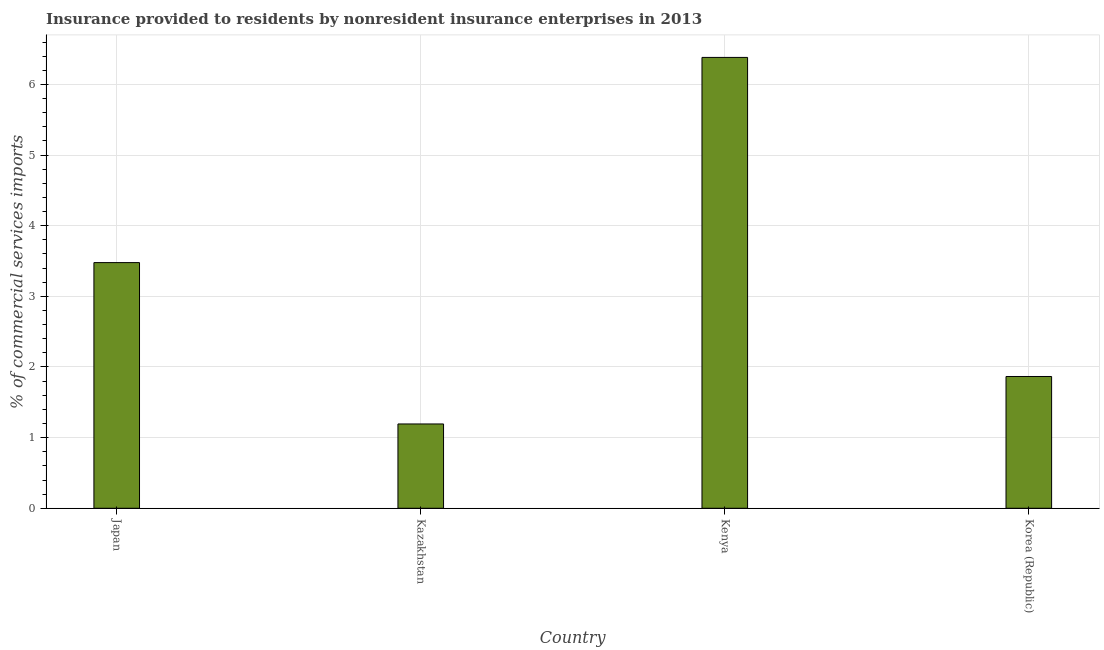What is the title of the graph?
Keep it short and to the point. Insurance provided to residents by nonresident insurance enterprises in 2013. What is the label or title of the Y-axis?
Offer a very short reply. % of commercial services imports. What is the insurance provided by non-residents in Kenya?
Provide a succinct answer. 6.38. Across all countries, what is the maximum insurance provided by non-residents?
Make the answer very short. 6.38. Across all countries, what is the minimum insurance provided by non-residents?
Provide a short and direct response. 1.19. In which country was the insurance provided by non-residents maximum?
Your response must be concise. Kenya. In which country was the insurance provided by non-residents minimum?
Offer a very short reply. Kazakhstan. What is the sum of the insurance provided by non-residents?
Ensure brevity in your answer.  12.92. What is the difference between the insurance provided by non-residents in Kazakhstan and Korea (Republic)?
Keep it short and to the point. -0.67. What is the average insurance provided by non-residents per country?
Keep it short and to the point. 3.23. What is the median insurance provided by non-residents?
Offer a very short reply. 2.67. In how many countries, is the insurance provided by non-residents greater than 4.8 %?
Your response must be concise. 1. What is the ratio of the insurance provided by non-residents in Kenya to that in Korea (Republic)?
Give a very brief answer. 3.42. Is the insurance provided by non-residents in Kazakhstan less than that in Kenya?
Give a very brief answer. Yes. Is the difference between the insurance provided by non-residents in Kazakhstan and Kenya greater than the difference between any two countries?
Keep it short and to the point. Yes. What is the difference between the highest and the second highest insurance provided by non-residents?
Keep it short and to the point. 2.9. Is the sum of the insurance provided by non-residents in Japan and Kenya greater than the maximum insurance provided by non-residents across all countries?
Provide a succinct answer. Yes. What is the difference between the highest and the lowest insurance provided by non-residents?
Your answer should be very brief. 5.19. How many bars are there?
Keep it short and to the point. 4. Are the values on the major ticks of Y-axis written in scientific E-notation?
Your answer should be compact. No. What is the % of commercial services imports in Japan?
Give a very brief answer. 3.48. What is the % of commercial services imports of Kazakhstan?
Your response must be concise. 1.19. What is the % of commercial services imports in Kenya?
Provide a succinct answer. 6.38. What is the % of commercial services imports of Korea (Republic)?
Ensure brevity in your answer.  1.87. What is the difference between the % of commercial services imports in Japan and Kazakhstan?
Your answer should be very brief. 2.28. What is the difference between the % of commercial services imports in Japan and Kenya?
Offer a very short reply. -2.9. What is the difference between the % of commercial services imports in Japan and Korea (Republic)?
Give a very brief answer. 1.61. What is the difference between the % of commercial services imports in Kazakhstan and Kenya?
Ensure brevity in your answer.  -5.19. What is the difference between the % of commercial services imports in Kazakhstan and Korea (Republic)?
Your response must be concise. -0.67. What is the difference between the % of commercial services imports in Kenya and Korea (Republic)?
Ensure brevity in your answer.  4.52. What is the ratio of the % of commercial services imports in Japan to that in Kazakhstan?
Ensure brevity in your answer.  2.91. What is the ratio of the % of commercial services imports in Japan to that in Kenya?
Give a very brief answer. 0.55. What is the ratio of the % of commercial services imports in Japan to that in Korea (Republic)?
Give a very brief answer. 1.86. What is the ratio of the % of commercial services imports in Kazakhstan to that in Kenya?
Keep it short and to the point. 0.19. What is the ratio of the % of commercial services imports in Kazakhstan to that in Korea (Republic)?
Your answer should be very brief. 0.64. What is the ratio of the % of commercial services imports in Kenya to that in Korea (Republic)?
Provide a succinct answer. 3.42. 